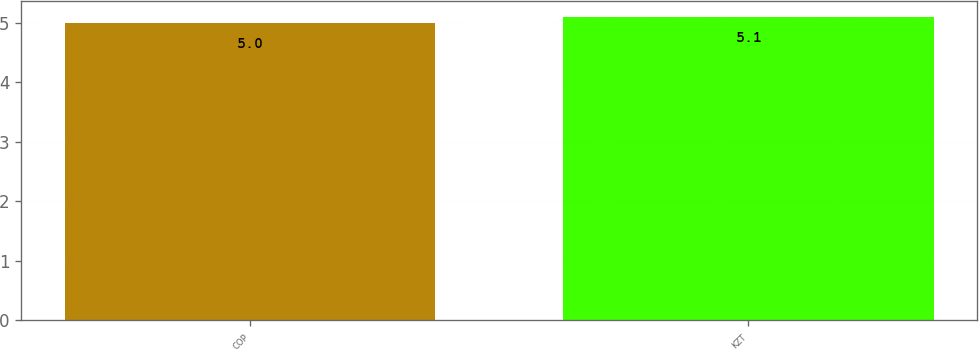Convert chart to OTSL. <chart><loc_0><loc_0><loc_500><loc_500><bar_chart><fcel>COP<fcel>KZT<nl><fcel>5<fcel>5.1<nl></chart> 